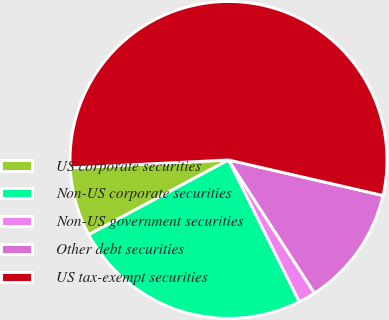Convert chart. <chart><loc_0><loc_0><loc_500><loc_500><pie_chart><fcel>US corporate securities<fcel>Non-US corporate securities<fcel>Non-US government securities<fcel>Other debt securities<fcel>US tax-exempt securities<nl><fcel>7.02%<fcel>24.56%<fcel>1.75%<fcel>12.28%<fcel>54.39%<nl></chart> 